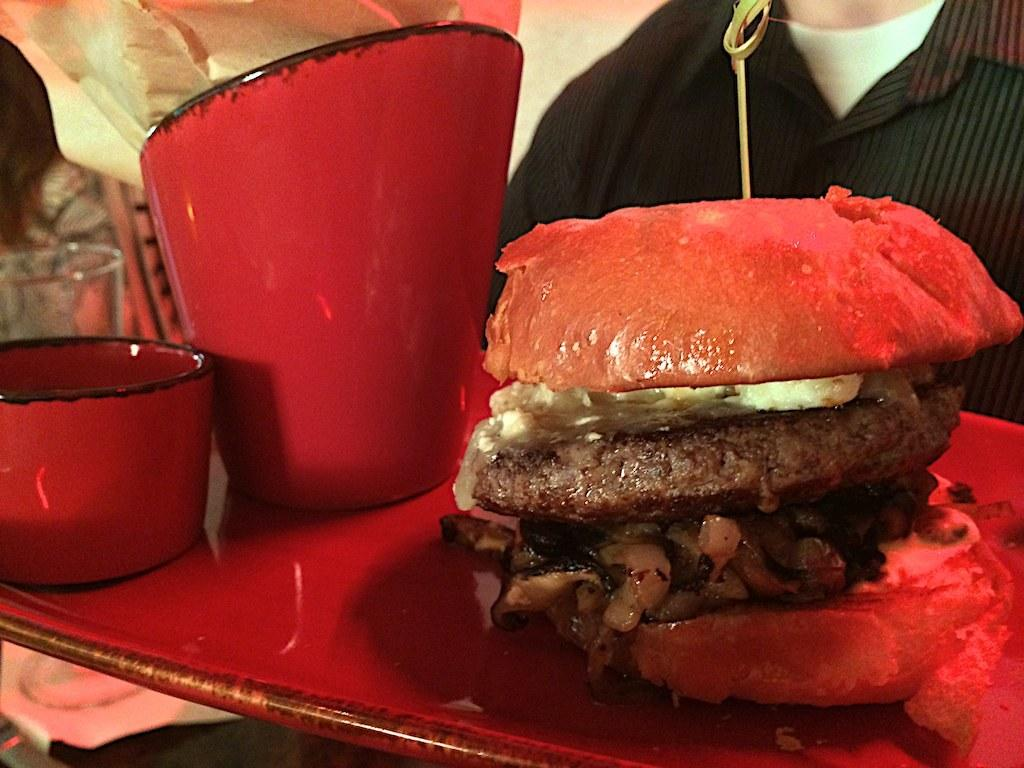What type of food is on the tray in the image? There is a burger on the tray in the image. What else is on the tray besides the burger? There is a cup and a bowl on the tray. Can you describe the person visible in the background of the image? There is a person visible in the background of the image, but no specific details about the person are provided. What other objects can be seen in the background of the image? There are other objects present in the background of the image, but no specific details about these objects are provided. What type of creature is crawling out of the burger in the image? There is no creature visible in the image, and the burger appears to be a regular food item. 